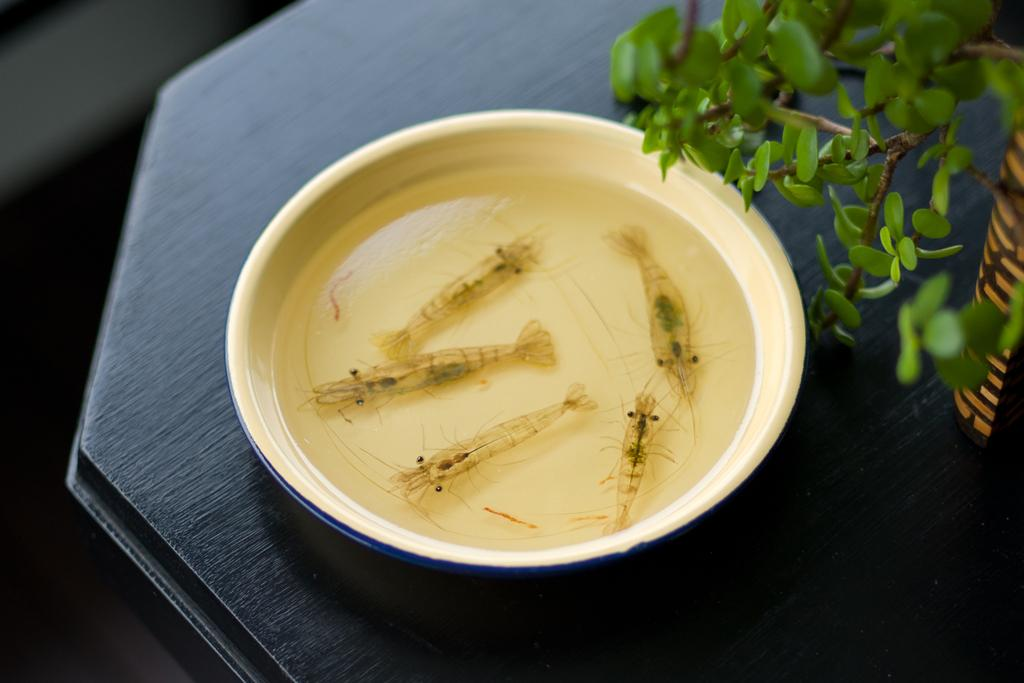What is in the bowl that is visible in the image? There is water in the bowl. What else can be seen in the bowl? There are five fish in the bowl. On what surface is the bowl placed? The bowl is on a wooden surface. What is present on the right side of the image? There is a plant and an object on the right side of the image. How many books are stacked on the left side of the image? There are no books present in the image. What type of ice can be seen melting in the bowl? There is no ice present in the image; it contains water and fish. 